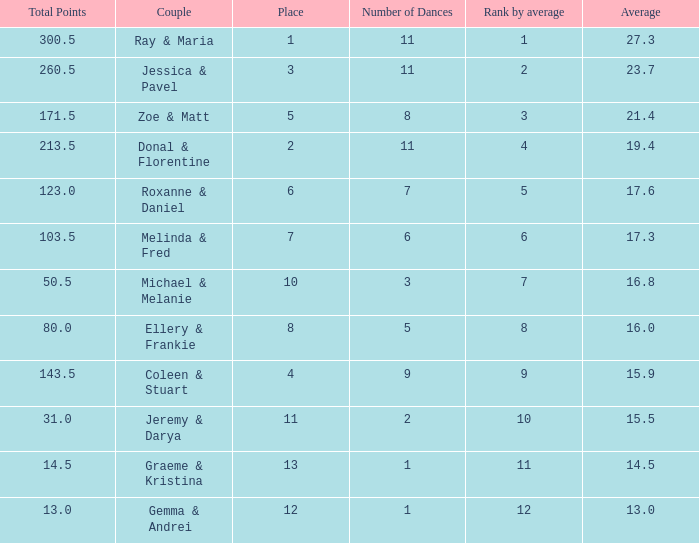What place would you be in if your rank by average is less than 2.0? 1.0. 